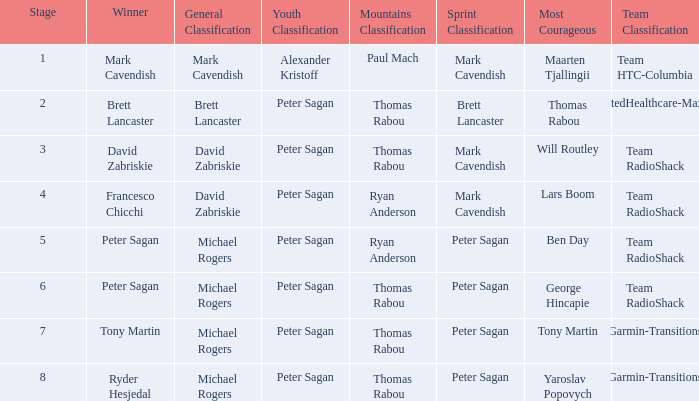Who claimed the mountains classification when maarten tjallingii secured most courageous? Paul Mach. 